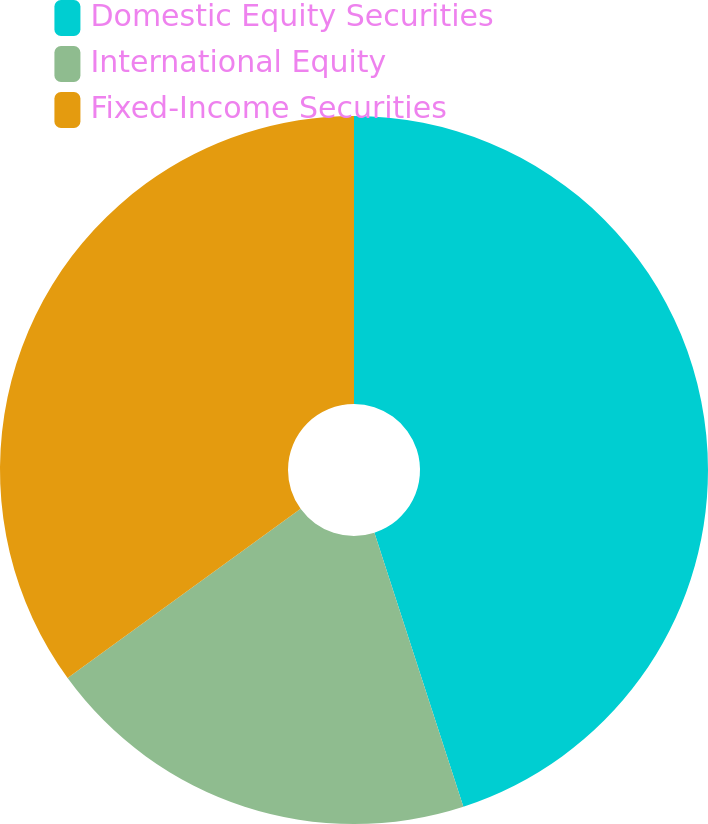Convert chart to OTSL. <chart><loc_0><loc_0><loc_500><loc_500><pie_chart><fcel>Domestic Equity Securities<fcel>International Equity<fcel>Fixed-Income Securities<nl><fcel>45.0%<fcel>20.0%<fcel>35.0%<nl></chart> 